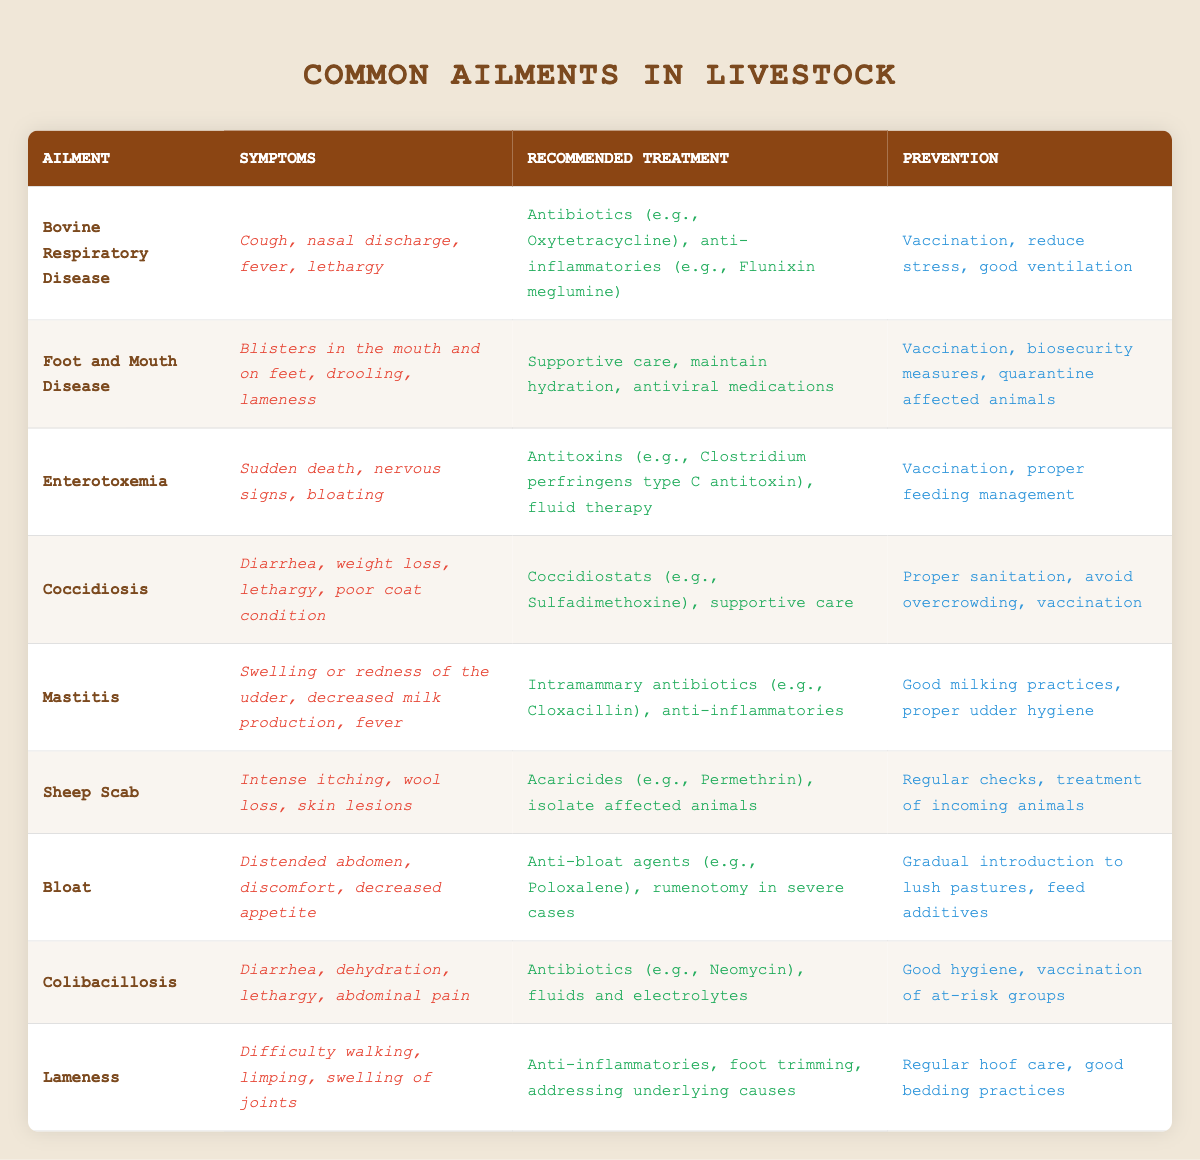What are the symptoms of Bovine Respiratory Disease? The table lists "Cough, nasal discharge, fever, lethargy" as the symptoms of Bovine Respiratory Disease.
Answer: Cough, nasal discharge, fever, lethargy Which treatment is recommended for Foot and Mouth Disease? According to the table, the recommended treatment for Foot and Mouth Disease includes "Supportive care, maintain hydration, antiviral medications."
Answer: Supportive care, maintain hydration, antiviral medications Is vaccination a prevention method for Enterotoxemia? The table states that vaccination is a prevention method for Enterotoxemia. Thus, the answer is yes.
Answer: Yes What is the recommended prevention for Coccidiosis? The table indicates that the prevention methods for Coccidiosis are "Proper sanitation, avoid overcrowding, vaccination."
Answer: Proper sanitation, avoid overcrowding, vaccination Does Mastitis have any connection to decreased milk production? Yes, the table mentions "decreased milk production" as one of the symptoms of Mastitis.
Answer: Yes Which ailment has "Distended abdomen" as a symptom? Referring to the table, "Bloat" is listed with "Distended abdomen" as one of its symptoms.
Answer: Bloat How many ailments listed have vaccination as a prevention method? By examining the table, vaccination is mentioned for Bovine Respiratory Disease, Foot and Mouth Disease, Enterotoxemia, Coccidiosis, and Colibacillosis. This totals five ailments.
Answer: Five What are the treatment options for Lameness? The table lists "Anti-inflammatories, foot trimming, addressing underlying causes" as the treatments for Lameness.
Answer: Anti-inflammatories, foot trimming, addressing underlying causes Is there a specific prevention method for Sheep Scab mentioned in the table? Yes, the prevention method listed for Sheep Scab includes "Regular checks, treatment of incoming animals."
Answer: Yes Which treatment is common to both Coccidiosis and Lameness? The table does not show any common treatment between Coccidiosis and Lameness, as their treatments differ significantly.
Answer: No 